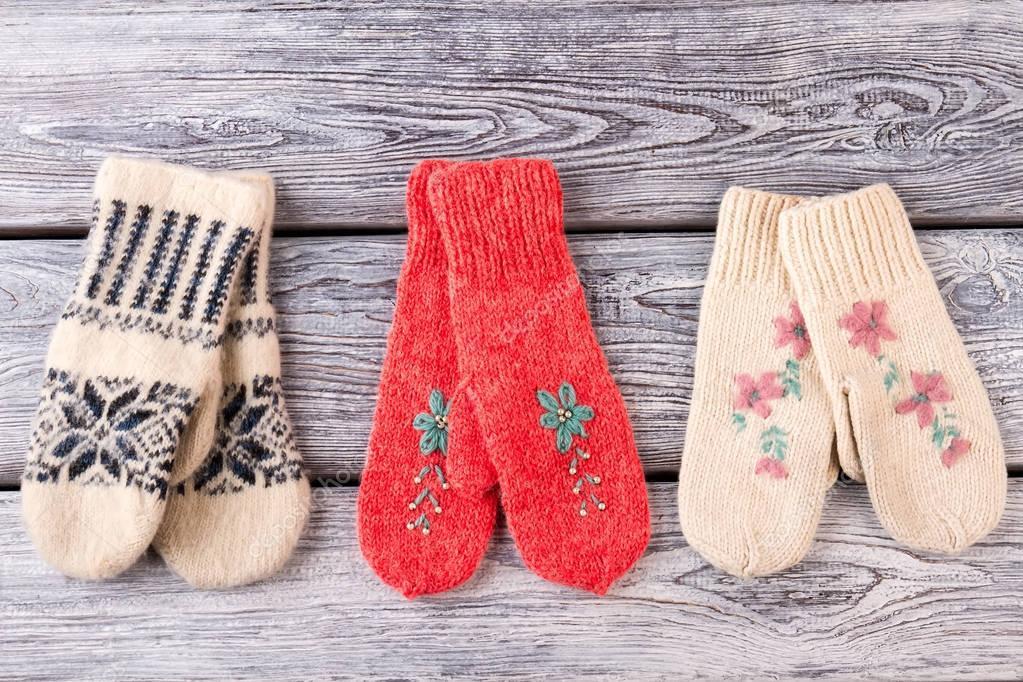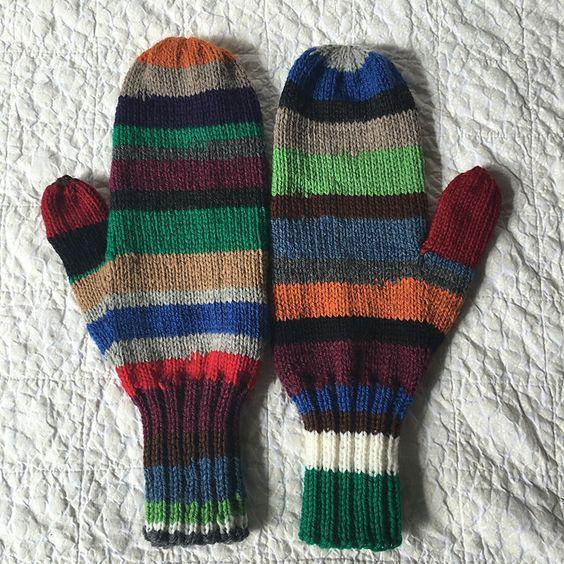The first image is the image on the left, the second image is the image on the right. For the images displayed, is the sentence "No image shows more than one pair of """"mittens"""" or any other wearable item, and at least one mitten pair has gray and dark red colors." factually correct? Answer yes or no. No. The first image is the image on the left, the second image is the image on the right. Assess this claim about the two images: "One pair of knit gloves are being worn on someone's hands.". Correct or not? Answer yes or no. No. 